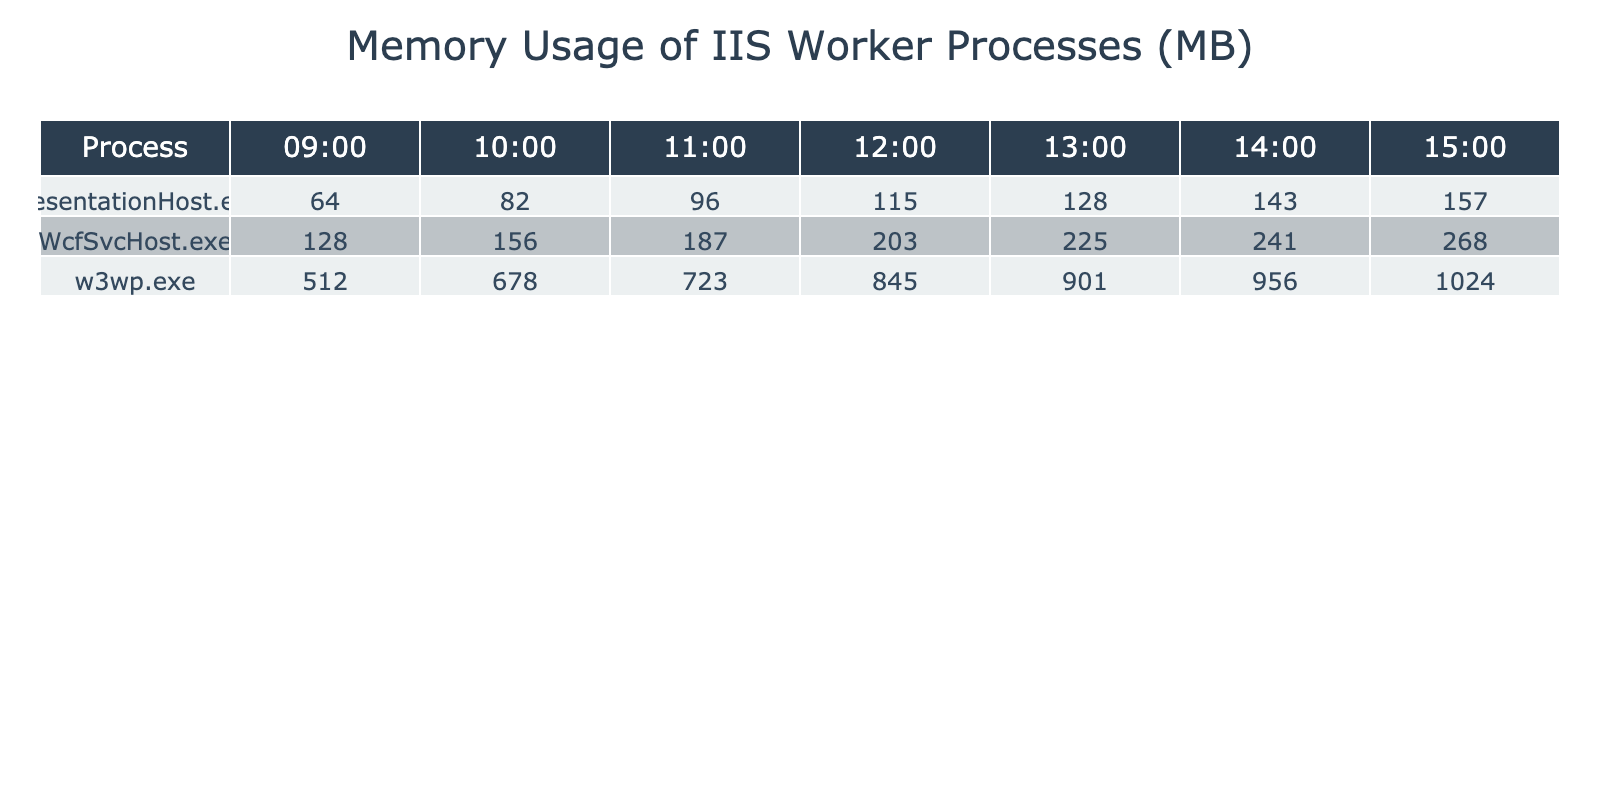What is the maximum memory usage recorded for w3wp.exe? The maximum memory usage for w3wp.exe can be found by looking at the values in its row across the time slots. The highest value listed is 1024 MB at 15:00.
Answer: 1024 MB What is the memory usage of WcfSvcHost.exe at 12:00? To answer this, we check the row for WcfSvcHost.exe and look across to the column for 12:00. The value there is 203 MB.
Answer: 203 MB Which process has the lowest memory usage at 09:00? By comparing the values of all processes at 09:00, we find that PresentationHost.exe has the lowest memory usage of 64 MB.
Answer: 64 MB What is the average memory usage of PresentationHost.exe from 09:00 to 15:00? We sum the values of PresentationHost.exe from 09:00 (64 MB) to 15:00 (157 MB): 64 + 82 + 96 + 115 + 128 + 143 + 157 = 785 MB. Then we divide by the number of hours, which is 7. Thus, the average is 785 / 7 ≈ 112.14 MB.
Answer: 112.14 MB Did the memory usage of WcfSvcHost.exe exceed 250 MB at any time? By examining the values for WcfSvcHost.exe, we see the highest usage recorded is 268 MB at 15:00, which is indeed over 250 MB.
Answer: Yes What is the difference in memory usage between w3wp.exe and PresentationHost.exe at 14:00? We can find the values for both processes at 14:00: w3wp.exe uses 956 MB, and PresentationHost.exe uses 143 MB. The difference is 956 - 143 = 813 MB.
Answer: 813 MB Which process had a memory usage increase that is greater than 200 MB from 09:00 to 15:00? To answer this, we can compare the memory usage of each process at 09:00 and 15:00. For w3wp.exe, the increase is 1024 - 512 = 512 MB; for WcfSvcHost.exe, it is 268 - 128 = 140 MB; and for PresentationHost.exe, it is 157 - 64 = 93 MB. Only w3wp.exe has an increase greater than 200 MB.
Answer: w3wp.exe What was the total memory usage of all processes at 11:00? We total the memory usage of all processes at 11:00: w3wp.exe (723 MB) + WcfSvcHost.exe (187 MB) + PresentationHost.exe (96 MB) = 1006 MB.
Answer: 1006 MB At what time did WcfSvcHost.exe see its highest usage? Looking at the values for WcfSvcHost.exe, the highest memory usage is 268 MB recorded at 15:00.
Answer: 15:00 What is the trend of memory usage from 09:00 to 15:00 for w3wp.exe? By observing the values for w3wp.exe across the time slots: 512, 678, 723, 845, 901, 956, 1024, we see a consistent and increasing trend throughout the day.
Answer: Increasing trend 